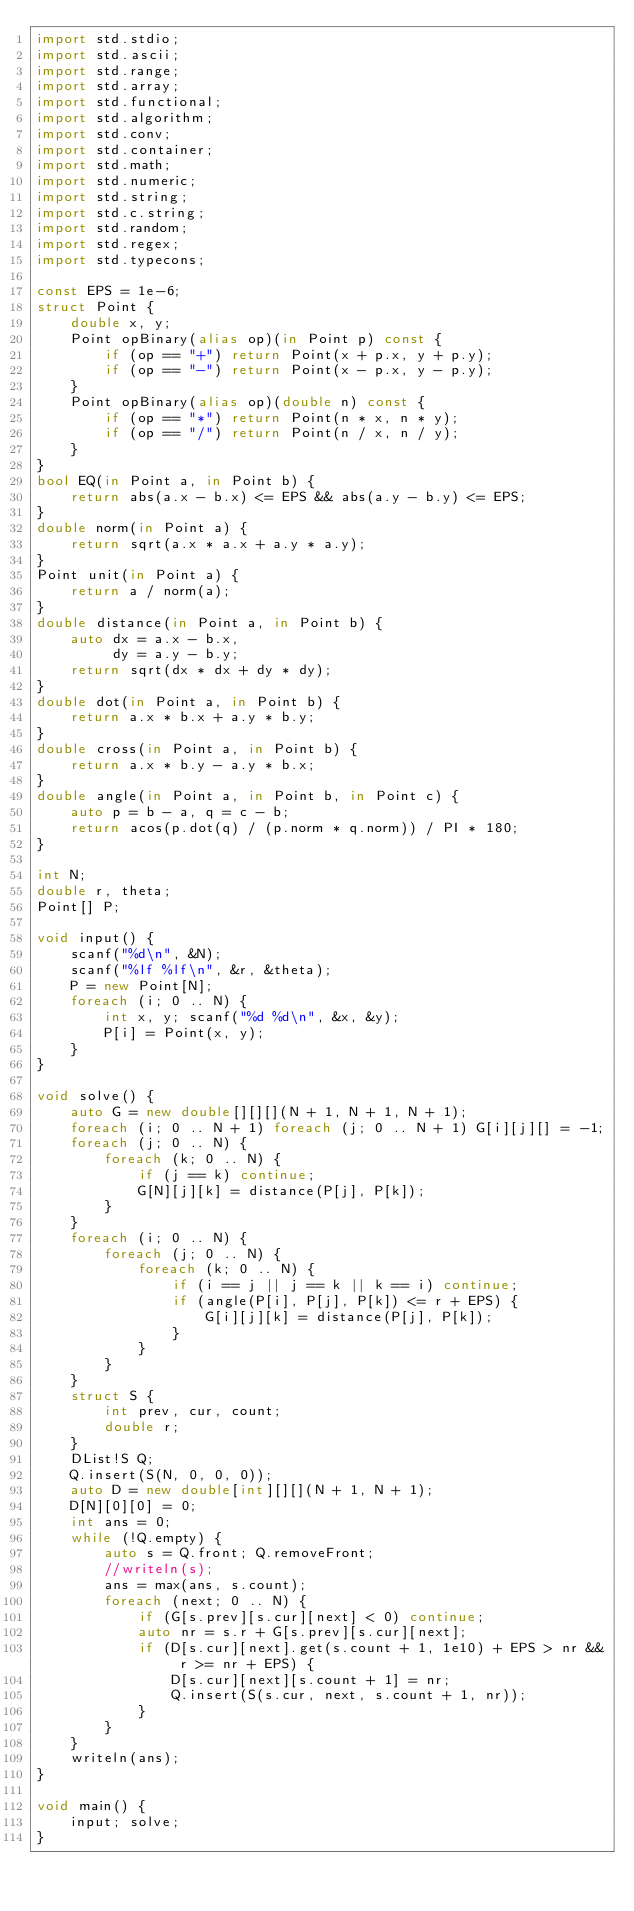<code> <loc_0><loc_0><loc_500><loc_500><_D_>import std.stdio;
import std.ascii;
import std.range;
import std.array;
import std.functional;
import std.algorithm;
import std.conv;
import std.container;
import std.math;
import std.numeric;
import std.string;
import std.c.string;
import std.random;
import std.regex;
import std.typecons;

const EPS = 1e-6;
struct Point {
    double x, y;
    Point opBinary(alias op)(in Point p) const {
        if (op == "+") return Point(x + p.x, y + p.y);
        if (op == "-") return Point(x - p.x, y - p.y);
    }
    Point opBinary(alias op)(double n) const {
        if (op == "*") return Point(n * x, n * y);
        if (op == "/") return Point(n / x, n / y);
    }
}
bool EQ(in Point a, in Point b) {
    return abs(a.x - b.x) <= EPS && abs(a.y - b.y) <= EPS;
}
double norm(in Point a) {
    return sqrt(a.x * a.x + a.y * a.y);
}
Point unit(in Point a) {
    return a / norm(a);
}
double distance(in Point a, in Point b) {
    auto dx = a.x - b.x,
         dy = a.y - b.y;
    return sqrt(dx * dx + dy * dy);
}
double dot(in Point a, in Point b) {
    return a.x * b.x + a.y * b.y;
}
double cross(in Point a, in Point b) {
    return a.x * b.y - a.y * b.x;
}
double angle(in Point a, in Point b, in Point c) {
    auto p = b - a, q = c - b;
    return acos(p.dot(q) / (p.norm * q.norm)) / PI * 180;
}

int N;
double r, theta;
Point[] P;

void input() {
    scanf("%d\n", &N);
    scanf("%lf %lf\n", &r, &theta);
    P = new Point[N];
    foreach (i; 0 .. N) {
        int x, y; scanf("%d %d\n", &x, &y);
        P[i] = Point(x, y);
    }
}

void solve() {
    auto G = new double[][][](N + 1, N + 1, N + 1);
    foreach (i; 0 .. N + 1) foreach (j; 0 .. N + 1) G[i][j][] = -1;
    foreach (j; 0 .. N) {
        foreach (k; 0 .. N) {
            if (j == k) continue;
            G[N][j][k] = distance(P[j], P[k]);
        }
    }
    foreach (i; 0 .. N) {
        foreach (j; 0 .. N) {
            foreach (k; 0 .. N) {
                if (i == j || j == k || k == i) continue;
                if (angle(P[i], P[j], P[k]) <= r + EPS) {
                    G[i][j][k] = distance(P[j], P[k]);
                }
            }
        }
    }
    struct S {
        int prev, cur, count;
        double r;
    }
    DList!S Q;
    Q.insert(S(N, 0, 0, 0));
    auto D = new double[int][][](N + 1, N + 1);
    D[N][0][0] = 0;
    int ans = 0;
    while (!Q.empty) {
        auto s = Q.front; Q.removeFront;
        //writeln(s);
        ans = max(ans, s.count);
        foreach (next; 0 .. N) {
            if (G[s.prev][s.cur][next] < 0) continue;
            auto nr = s.r + G[s.prev][s.cur][next];
            if (D[s.cur][next].get(s.count + 1, 1e10) + EPS > nr && r >= nr + EPS) {
                D[s.cur][next][s.count + 1] = nr;
                Q.insert(S(s.cur, next, s.count + 1, nr));
            }
        }
    }
    writeln(ans);
}

void main() {
    input; solve;
}</code> 